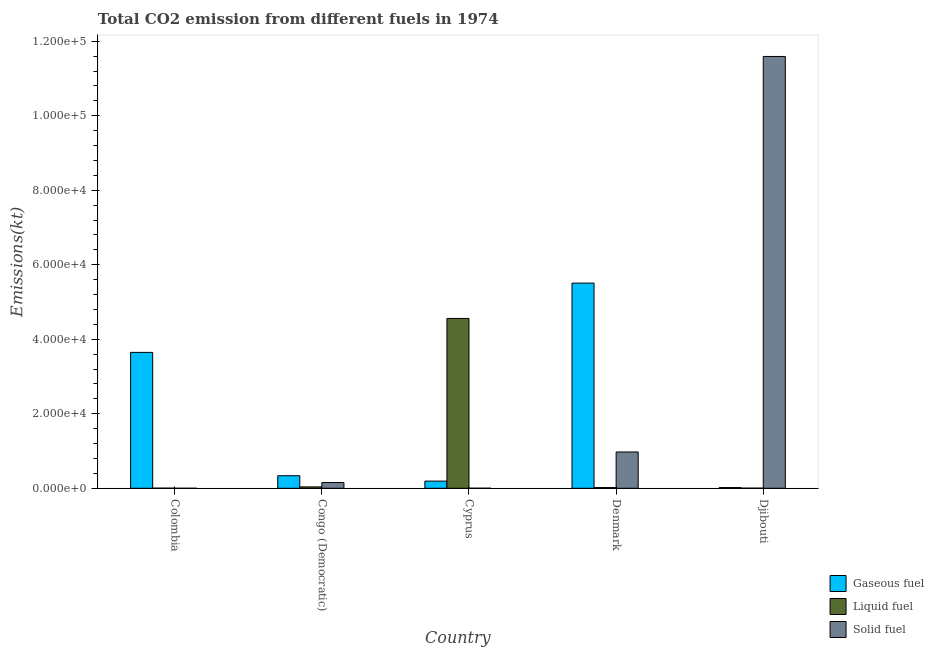How many different coloured bars are there?
Ensure brevity in your answer.  3. How many groups of bars are there?
Provide a short and direct response. 5. Are the number of bars per tick equal to the number of legend labels?
Your answer should be compact. Yes. How many bars are there on the 1st tick from the left?
Provide a succinct answer. 3. In how many cases, is the number of bars for a given country not equal to the number of legend labels?
Provide a succinct answer. 0. What is the amount of co2 emissions from liquid fuel in Cyprus?
Provide a short and direct response. 4.56e+04. Across all countries, what is the maximum amount of co2 emissions from gaseous fuel?
Provide a succinct answer. 5.51e+04. Across all countries, what is the minimum amount of co2 emissions from liquid fuel?
Ensure brevity in your answer.  29.34. In which country was the amount of co2 emissions from gaseous fuel maximum?
Provide a succinct answer. Denmark. In which country was the amount of co2 emissions from gaseous fuel minimum?
Provide a short and direct response. Djibouti. What is the total amount of co2 emissions from solid fuel in the graph?
Ensure brevity in your answer.  1.27e+05. What is the difference between the amount of co2 emissions from liquid fuel in Denmark and that in Djibouti?
Your response must be concise. 165.01. What is the difference between the amount of co2 emissions from solid fuel in Denmark and the amount of co2 emissions from liquid fuel in Cyprus?
Give a very brief answer. -3.58e+04. What is the average amount of co2 emissions from liquid fuel per country?
Your answer should be compact. 9243.04. What is the difference between the amount of co2 emissions from gaseous fuel and amount of co2 emissions from liquid fuel in Colombia?
Your answer should be compact. 3.64e+04. What is the ratio of the amount of co2 emissions from gaseous fuel in Cyprus to that in Denmark?
Keep it short and to the point. 0.03. Is the amount of co2 emissions from solid fuel in Colombia less than that in Cyprus?
Keep it short and to the point. Yes. What is the difference between the highest and the second highest amount of co2 emissions from liquid fuel?
Ensure brevity in your answer.  4.52e+04. What is the difference between the highest and the lowest amount of co2 emissions from gaseous fuel?
Ensure brevity in your answer.  5.49e+04. What does the 3rd bar from the left in Congo (Democratic) represents?
Ensure brevity in your answer.  Solid fuel. What does the 1st bar from the right in Djibouti represents?
Ensure brevity in your answer.  Solid fuel. Is it the case that in every country, the sum of the amount of co2 emissions from gaseous fuel and amount of co2 emissions from liquid fuel is greater than the amount of co2 emissions from solid fuel?
Give a very brief answer. No. Are all the bars in the graph horizontal?
Provide a succinct answer. No. Does the graph contain grids?
Your response must be concise. No. What is the title of the graph?
Offer a very short reply. Total CO2 emission from different fuels in 1974. What is the label or title of the X-axis?
Provide a succinct answer. Country. What is the label or title of the Y-axis?
Keep it short and to the point. Emissions(kt). What is the Emissions(kt) in Gaseous fuel in Colombia?
Make the answer very short. 3.65e+04. What is the Emissions(kt) in Liquid fuel in Colombia?
Provide a short and direct response. 29.34. What is the Emissions(kt) in Solid fuel in Colombia?
Ensure brevity in your answer.  3.67. What is the Emissions(kt) in Gaseous fuel in Congo (Democratic)?
Offer a terse response. 3369.97. What is the Emissions(kt) of Liquid fuel in Congo (Democratic)?
Provide a succinct answer. 370.37. What is the Emissions(kt) of Solid fuel in Congo (Democratic)?
Ensure brevity in your answer.  1543.81. What is the Emissions(kt) in Gaseous fuel in Cyprus?
Provide a short and direct response. 1925.17. What is the Emissions(kt) of Liquid fuel in Cyprus?
Ensure brevity in your answer.  4.56e+04. What is the Emissions(kt) of Solid fuel in Cyprus?
Offer a very short reply. 18.34. What is the Emissions(kt) of Gaseous fuel in Denmark?
Offer a very short reply. 5.51e+04. What is the Emissions(kt) of Liquid fuel in Denmark?
Your answer should be compact. 194.35. What is the Emissions(kt) of Solid fuel in Denmark?
Your answer should be very brief. 9746.89. What is the Emissions(kt) of Gaseous fuel in Djibouti?
Give a very brief answer. 194.35. What is the Emissions(kt) of Liquid fuel in Djibouti?
Provide a succinct answer. 29.34. What is the Emissions(kt) of Solid fuel in Djibouti?
Offer a terse response. 1.16e+05. Across all countries, what is the maximum Emissions(kt) in Gaseous fuel?
Ensure brevity in your answer.  5.51e+04. Across all countries, what is the maximum Emissions(kt) in Liquid fuel?
Your answer should be very brief. 4.56e+04. Across all countries, what is the maximum Emissions(kt) in Solid fuel?
Your answer should be very brief. 1.16e+05. Across all countries, what is the minimum Emissions(kt) in Gaseous fuel?
Offer a terse response. 194.35. Across all countries, what is the minimum Emissions(kt) of Liquid fuel?
Your answer should be very brief. 29.34. Across all countries, what is the minimum Emissions(kt) of Solid fuel?
Offer a very short reply. 3.67. What is the total Emissions(kt) of Gaseous fuel in the graph?
Offer a very short reply. 9.70e+04. What is the total Emissions(kt) in Liquid fuel in the graph?
Make the answer very short. 4.62e+04. What is the total Emissions(kt) in Solid fuel in the graph?
Make the answer very short. 1.27e+05. What is the difference between the Emissions(kt) of Gaseous fuel in Colombia and that in Congo (Democratic)?
Offer a very short reply. 3.31e+04. What is the difference between the Emissions(kt) of Liquid fuel in Colombia and that in Congo (Democratic)?
Provide a succinct answer. -341.03. What is the difference between the Emissions(kt) in Solid fuel in Colombia and that in Congo (Democratic)?
Provide a short and direct response. -1540.14. What is the difference between the Emissions(kt) in Gaseous fuel in Colombia and that in Cyprus?
Make the answer very short. 3.46e+04. What is the difference between the Emissions(kt) of Liquid fuel in Colombia and that in Cyprus?
Keep it short and to the point. -4.56e+04. What is the difference between the Emissions(kt) of Solid fuel in Colombia and that in Cyprus?
Make the answer very short. -14.67. What is the difference between the Emissions(kt) of Gaseous fuel in Colombia and that in Denmark?
Offer a terse response. -1.86e+04. What is the difference between the Emissions(kt) in Liquid fuel in Colombia and that in Denmark?
Provide a short and direct response. -165.01. What is the difference between the Emissions(kt) in Solid fuel in Colombia and that in Denmark?
Provide a short and direct response. -9743.22. What is the difference between the Emissions(kt) of Gaseous fuel in Colombia and that in Djibouti?
Your answer should be compact. 3.63e+04. What is the difference between the Emissions(kt) in Liquid fuel in Colombia and that in Djibouti?
Your answer should be compact. 0. What is the difference between the Emissions(kt) of Solid fuel in Colombia and that in Djibouti?
Keep it short and to the point. -1.16e+05. What is the difference between the Emissions(kt) in Gaseous fuel in Congo (Democratic) and that in Cyprus?
Ensure brevity in your answer.  1444.8. What is the difference between the Emissions(kt) in Liquid fuel in Congo (Democratic) and that in Cyprus?
Offer a terse response. -4.52e+04. What is the difference between the Emissions(kt) of Solid fuel in Congo (Democratic) and that in Cyprus?
Offer a very short reply. 1525.47. What is the difference between the Emissions(kt) in Gaseous fuel in Congo (Democratic) and that in Denmark?
Provide a short and direct response. -5.17e+04. What is the difference between the Emissions(kt) of Liquid fuel in Congo (Democratic) and that in Denmark?
Provide a short and direct response. 176.02. What is the difference between the Emissions(kt) of Solid fuel in Congo (Democratic) and that in Denmark?
Your answer should be very brief. -8203.08. What is the difference between the Emissions(kt) of Gaseous fuel in Congo (Democratic) and that in Djibouti?
Give a very brief answer. 3175.62. What is the difference between the Emissions(kt) of Liquid fuel in Congo (Democratic) and that in Djibouti?
Your answer should be compact. 341.03. What is the difference between the Emissions(kt) of Solid fuel in Congo (Democratic) and that in Djibouti?
Provide a succinct answer. -1.14e+05. What is the difference between the Emissions(kt) in Gaseous fuel in Cyprus and that in Denmark?
Keep it short and to the point. -5.32e+04. What is the difference between the Emissions(kt) in Liquid fuel in Cyprus and that in Denmark?
Ensure brevity in your answer.  4.54e+04. What is the difference between the Emissions(kt) in Solid fuel in Cyprus and that in Denmark?
Offer a terse response. -9728.55. What is the difference between the Emissions(kt) of Gaseous fuel in Cyprus and that in Djibouti?
Your response must be concise. 1730.82. What is the difference between the Emissions(kt) of Liquid fuel in Cyprus and that in Djibouti?
Keep it short and to the point. 4.56e+04. What is the difference between the Emissions(kt) of Solid fuel in Cyprus and that in Djibouti?
Keep it short and to the point. -1.16e+05. What is the difference between the Emissions(kt) in Gaseous fuel in Denmark and that in Djibouti?
Provide a short and direct response. 5.49e+04. What is the difference between the Emissions(kt) in Liquid fuel in Denmark and that in Djibouti?
Your answer should be compact. 165.01. What is the difference between the Emissions(kt) in Solid fuel in Denmark and that in Djibouti?
Give a very brief answer. -1.06e+05. What is the difference between the Emissions(kt) in Gaseous fuel in Colombia and the Emissions(kt) in Liquid fuel in Congo (Democratic)?
Your answer should be very brief. 3.61e+04. What is the difference between the Emissions(kt) of Gaseous fuel in Colombia and the Emissions(kt) of Solid fuel in Congo (Democratic)?
Keep it short and to the point. 3.49e+04. What is the difference between the Emissions(kt) of Liquid fuel in Colombia and the Emissions(kt) of Solid fuel in Congo (Democratic)?
Your response must be concise. -1514.47. What is the difference between the Emissions(kt) in Gaseous fuel in Colombia and the Emissions(kt) in Liquid fuel in Cyprus?
Make the answer very short. -9112.5. What is the difference between the Emissions(kt) in Gaseous fuel in Colombia and the Emissions(kt) in Solid fuel in Cyprus?
Provide a succinct answer. 3.65e+04. What is the difference between the Emissions(kt) in Liquid fuel in Colombia and the Emissions(kt) in Solid fuel in Cyprus?
Offer a terse response. 11. What is the difference between the Emissions(kt) in Gaseous fuel in Colombia and the Emissions(kt) in Liquid fuel in Denmark?
Provide a succinct answer. 3.63e+04. What is the difference between the Emissions(kt) of Gaseous fuel in Colombia and the Emissions(kt) of Solid fuel in Denmark?
Your response must be concise. 2.67e+04. What is the difference between the Emissions(kt) of Liquid fuel in Colombia and the Emissions(kt) of Solid fuel in Denmark?
Ensure brevity in your answer.  -9717.55. What is the difference between the Emissions(kt) of Gaseous fuel in Colombia and the Emissions(kt) of Liquid fuel in Djibouti?
Give a very brief answer. 3.64e+04. What is the difference between the Emissions(kt) of Gaseous fuel in Colombia and the Emissions(kt) of Solid fuel in Djibouti?
Give a very brief answer. -7.94e+04. What is the difference between the Emissions(kt) of Liquid fuel in Colombia and the Emissions(kt) of Solid fuel in Djibouti?
Provide a succinct answer. -1.16e+05. What is the difference between the Emissions(kt) in Gaseous fuel in Congo (Democratic) and the Emissions(kt) in Liquid fuel in Cyprus?
Make the answer very short. -4.22e+04. What is the difference between the Emissions(kt) of Gaseous fuel in Congo (Democratic) and the Emissions(kt) of Solid fuel in Cyprus?
Your answer should be compact. 3351.64. What is the difference between the Emissions(kt) of Liquid fuel in Congo (Democratic) and the Emissions(kt) of Solid fuel in Cyprus?
Provide a succinct answer. 352.03. What is the difference between the Emissions(kt) in Gaseous fuel in Congo (Democratic) and the Emissions(kt) in Liquid fuel in Denmark?
Your answer should be compact. 3175.62. What is the difference between the Emissions(kt) in Gaseous fuel in Congo (Democratic) and the Emissions(kt) in Solid fuel in Denmark?
Give a very brief answer. -6376.91. What is the difference between the Emissions(kt) of Liquid fuel in Congo (Democratic) and the Emissions(kt) of Solid fuel in Denmark?
Provide a succinct answer. -9376.52. What is the difference between the Emissions(kt) in Gaseous fuel in Congo (Democratic) and the Emissions(kt) in Liquid fuel in Djibouti?
Make the answer very short. 3340.64. What is the difference between the Emissions(kt) of Gaseous fuel in Congo (Democratic) and the Emissions(kt) of Solid fuel in Djibouti?
Keep it short and to the point. -1.13e+05. What is the difference between the Emissions(kt) of Liquid fuel in Congo (Democratic) and the Emissions(kt) of Solid fuel in Djibouti?
Your answer should be very brief. -1.16e+05. What is the difference between the Emissions(kt) in Gaseous fuel in Cyprus and the Emissions(kt) in Liquid fuel in Denmark?
Offer a terse response. 1730.82. What is the difference between the Emissions(kt) in Gaseous fuel in Cyprus and the Emissions(kt) in Solid fuel in Denmark?
Your answer should be very brief. -7821.71. What is the difference between the Emissions(kt) in Liquid fuel in Cyprus and the Emissions(kt) in Solid fuel in Denmark?
Give a very brief answer. 3.58e+04. What is the difference between the Emissions(kt) of Gaseous fuel in Cyprus and the Emissions(kt) of Liquid fuel in Djibouti?
Offer a very short reply. 1895.84. What is the difference between the Emissions(kt) in Gaseous fuel in Cyprus and the Emissions(kt) in Solid fuel in Djibouti?
Your response must be concise. -1.14e+05. What is the difference between the Emissions(kt) in Liquid fuel in Cyprus and the Emissions(kt) in Solid fuel in Djibouti?
Offer a very short reply. -7.03e+04. What is the difference between the Emissions(kt) of Gaseous fuel in Denmark and the Emissions(kt) of Liquid fuel in Djibouti?
Make the answer very short. 5.50e+04. What is the difference between the Emissions(kt) of Gaseous fuel in Denmark and the Emissions(kt) of Solid fuel in Djibouti?
Provide a succinct answer. -6.08e+04. What is the difference between the Emissions(kt) in Liquid fuel in Denmark and the Emissions(kt) in Solid fuel in Djibouti?
Make the answer very short. -1.16e+05. What is the average Emissions(kt) in Gaseous fuel per country?
Ensure brevity in your answer.  1.94e+04. What is the average Emissions(kt) in Liquid fuel per country?
Your response must be concise. 9243.04. What is the average Emissions(kt) in Solid fuel per country?
Provide a short and direct response. 2.54e+04. What is the difference between the Emissions(kt) of Gaseous fuel and Emissions(kt) of Liquid fuel in Colombia?
Keep it short and to the point. 3.64e+04. What is the difference between the Emissions(kt) of Gaseous fuel and Emissions(kt) of Solid fuel in Colombia?
Offer a very short reply. 3.65e+04. What is the difference between the Emissions(kt) in Liquid fuel and Emissions(kt) in Solid fuel in Colombia?
Ensure brevity in your answer.  25.67. What is the difference between the Emissions(kt) of Gaseous fuel and Emissions(kt) of Liquid fuel in Congo (Democratic)?
Give a very brief answer. 2999.61. What is the difference between the Emissions(kt) of Gaseous fuel and Emissions(kt) of Solid fuel in Congo (Democratic)?
Offer a terse response. 1826.17. What is the difference between the Emissions(kt) in Liquid fuel and Emissions(kt) in Solid fuel in Congo (Democratic)?
Provide a short and direct response. -1173.44. What is the difference between the Emissions(kt) of Gaseous fuel and Emissions(kt) of Liquid fuel in Cyprus?
Offer a terse response. -4.37e+04. What is the difference between the Emissions(kt) of Gaseous fuel and Emissions(kt) of Solid fuel in Cyprus?
Make the answer very short. 1906.84. What is the difference between the Emissions(kt) in Liquid fuel and Emissions(kt) in Solid fuel in Cyprus?
Your response must be concise. 4.56e+04. What is the difference between the Emissions(kt) in Gaseous fuel and Emissions(kt) in Liquid fuel in Denmark?
Make the answer very short. 5.49e+04. What is the difference between the Emissions(kt) in Gaseous fuel and Emissions(kt) in Solid fuel in Denmark?
Make the answer very short. 4.53e+04. What is the difference between the Emissions(kt) of Liquid fuel and Emissions(kt) of Solid fuel in Denmark?
Provide a succinct answer. -9552.53. What is the difference between the Emissions(kt) of Gaseous fuel and Emissions(kt) of Liquid fuel in Djibouti?
Your answer should be very brief. 165.01. What is the difference between the Emissions(kt) in Gaseous fuel and Emissions(kt) in Solid fuel in Djibouti?
Offer a very short reply. -1.16e+05. What is the difference between the Emissions(kt) of Liquid fuel and Emissions(kt) of Solid fuel in Djibouti?
Ensure brevity in your answer.  -1.16e+05. What is the ratio of the Emissions(kt) in Gaseous fuel in Colombia to that in Congo (Democratic)?
Offer a very short reply. 10.82. What is the ratio of the Emissions(kt) of Liquid fuel in Colombia to that in Congo (Democratic)?
Offer a terse response. 0.08. What is the ratio of the Emissions(kt) in Solid fuel in Colombia to that in Congo (Democratic)?
Your response must be concise. 0. What is the ratio of the Emissions(kt) in Gaseous fuel in Colombia to that in Cyprus?
Make the answer very short. 18.95. What is the ratio of the Emissions(kt) in Liquid fuel in Colombia to that in Cyprus?
Give a very brief answer. 0. What is the ratio of the Emissions(kt) of Solid fuel in Colombia to that in Cyprus?
Provide a succinct answer. 0.2. What is the ratio of the Emissions(kt) of Gaseous fuel in Colombia to that in Denmark?
Provide a short and direct response. 0.66. What is the ratio of the Emissions(kt) in Liquid fuel in Colombia to that in Denmark?
Give a very brief answer. 0.15. What is the ratio of the Emissions(kt) of Gaseous fuel in Colombia to that in Djibouti?
Keep it short and to the point. 187.7. What is the ratio of the Emissions(kt) in Liquid fuel in Colombia to that in Djibouti?
Provide a short and direct response. 1. What is the ratio of the Emissions(kt) in Solid fuel in Colombia to that in Djibouti?
Ensure brevity in your answer.  0. What is the ratio of the Emissions(kt) of Gaseous fuel in Congo (Democratic) to that in Cyprus?
Ensure brevity in your answer.  1.75. What is the ratio of the Emissions(kt) of Liquid fuel in Congo (Democratic) to that in Cyprus?
Your answer should be compact. 0.01. What is the ratio of the Emissions(kt) in Solid fuel in Congo (Democratic) to that in Cyprus?
Your answer should be very brief. 84.2. What is the ratio of the Emissions(kt) of Gaseous fuel in Congo (Democratic) to that in Denmark?
Make the answer very short. 0.06. What is the ratio of the Emissions(kt) of Liquid fuel in Congo (Democratic) to that in Denmark?
Provide a short and direct response. 1.91. What is the ratio of the Emissions(kt) in Solid fuel in Congo (Democratic) to that in Denmark?
Your answer should be compact. 0.16. What is the ratio of the Emissions(kt) in Gaseous fuel in Congo (Democratic) to that in Djibouti?
Your response must be concise. 17.34. What is the ratio of the Emissions(kt) in Liquid fuel in Congo (Democratic) to that in Djibouti?
Offer a terse response. 12.62. What is the ratio of the Emissions(kt) in Solid fuel in Congo (Democratic) to that in Djibouti?
Make the answer very short. 0.01. What is the ratio of the Emissions(kt) of Gaseous fuel in Cyprus to that in Denmark?
Offer a terse response. 0.04. What is the ratio of the Emissions(kt) in Liquid fuel in Cyprus to that in Denmark?
Provide a succinct answer. 234.58. What is the ratio of the Emissions(kt) in Solid fuel in Cyprus to that in Denmark?
Your answer should be very brief. 0. What is the ratio of the Emissions(kt) in Gaseous fuel in Cyprus to that in Djibouti?
Offer a very short reply. 9.91. What is the ratio of the Emissions(kt) of Liquid fuel in Cyprus to that in Djibouti?
Ensure brevity in your answer.  1554.12. What is the ratio of the Emissions(kt) of Gaseous fuel in Denmark to that in Djibouti?
Your answer should be very brief. 283.4. What is the ratio of the Emissions(kt) of Liquid fuel in Denmark to that in Djibouti?
Your answer should be very brief. 6.62. What is the ratio of the Emissions(kt) of Solid fuel in Denmark to that in Djibouti?
Keep it short and to the point. 0.08. What is the difference between the highest and the second highest Emissions(kt) in Gaseous fuel?
Ensure brevity in your answer.  1.86e+04. What is the difference between the highest and the second highest Emissions(kt) in Liquid fuel?
Give a very brief answer. 4.52e+04. What is the difference between the highest and the second highest Emissions(kt) in Solid fuel?
Provide a succinct answer. 1.06e+05. What is the difference between the highest and the lowest Emissions(kt) in Gaseous fuel?
Give a very brief answer. 5.49e+04. What is the difference between the highest and the lowest Emissions(kt) in Liquid fuel?
Ensure brevity in your answer.  4.56e+04. What is the difference between the highest and the lowest Emissions(kt) of Solid fuel?
Keep it short and to the point. 1.16e+05. 